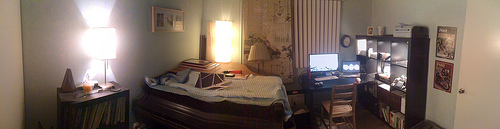Please provide a short description for this region: [0.04, 0.43, 0.12, 0.52]. This region of the image depicts a section of a white house wall that looks smooth and is bathed in a soft, ambient light, creating a calm corner in the room. 